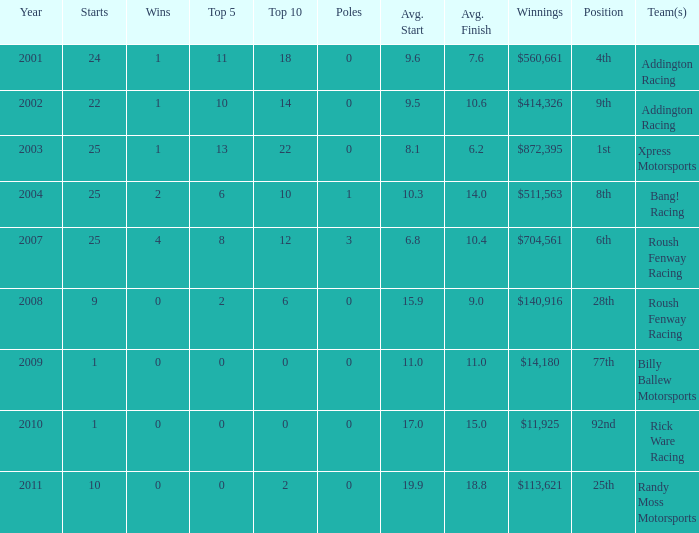In the top 10, can you identify any team or teams with 18? Addington Racing. 